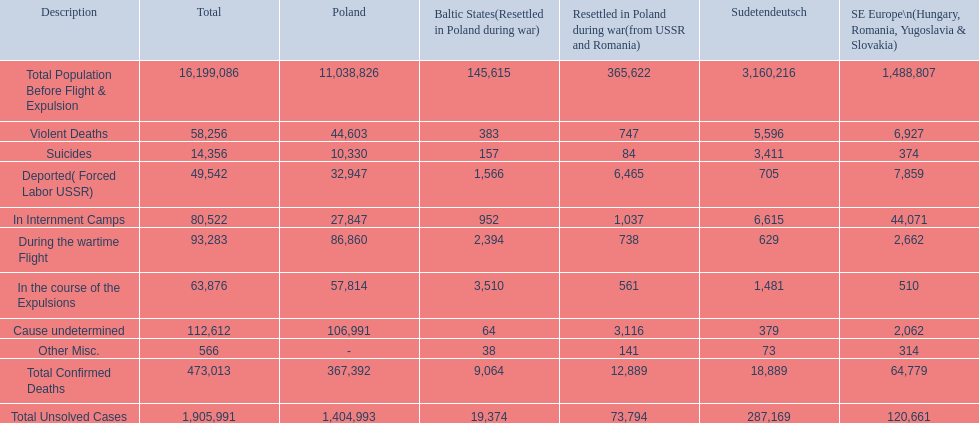What was the entire sum of confirmed casualties? 473,013. Of these, how many were aggressive? 58,256. 